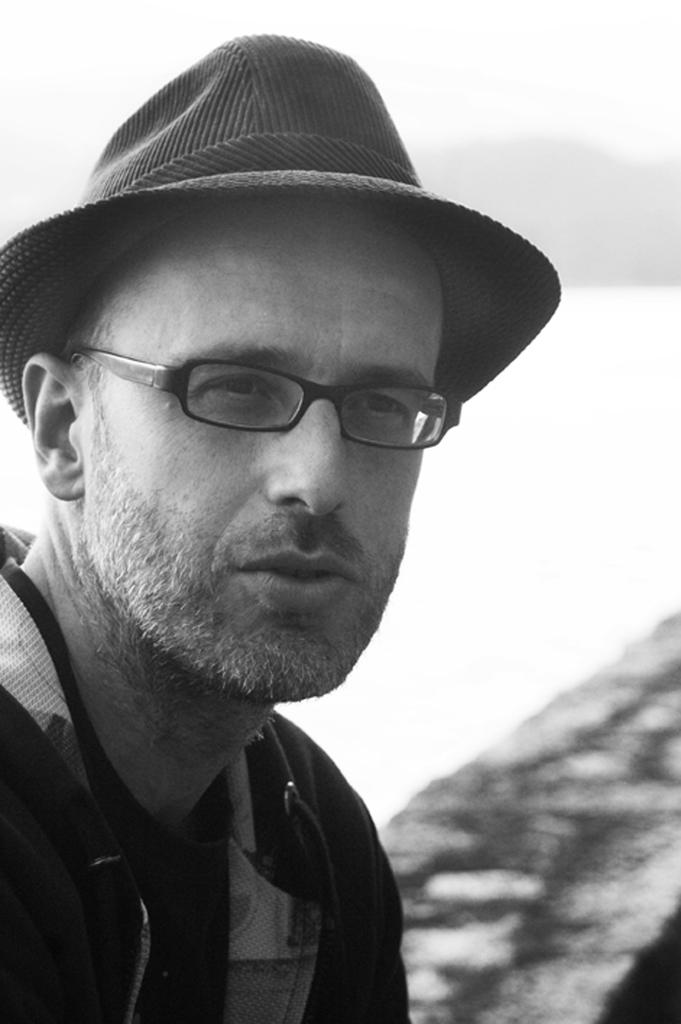What is the color scheme of the image? The image is black and white. Who is present in the image? There is a man in the picture. What accessories is the man wearing? The man is wearing spectacles and a hat. What can be seen in the bottom right corner of the image? There is a wall in the right bottom of the image. What is the color of the background in the image? The background of the image is white in color. How many items are on the list that the man is holding in the image? There is no list present in the image; the man is not holding anything. What type of cattle can be seen grazing in the background of the image? There are no cattle present in the image; the background is white. 